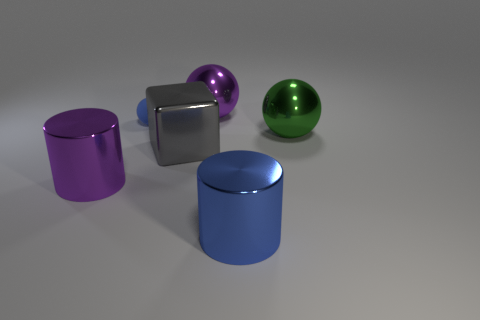Subtract all metallic spheres. How many spheres are left? 1 Add 4 tiny blue rubber spheres. How many objects exist? 10 Subtract all blocks. How many objects are left? 5 Add 5 green metallic spheres. How many green metallic spheres are left? 6 Add 2 tiny cyan matte things. How many tiny cyan matte things exist? 2 Subtract 0 brown cylinders. How many objects are left? 6 Subtract all cyan matte cubes. Subtract all large green metal things. How many objects are left? 5 